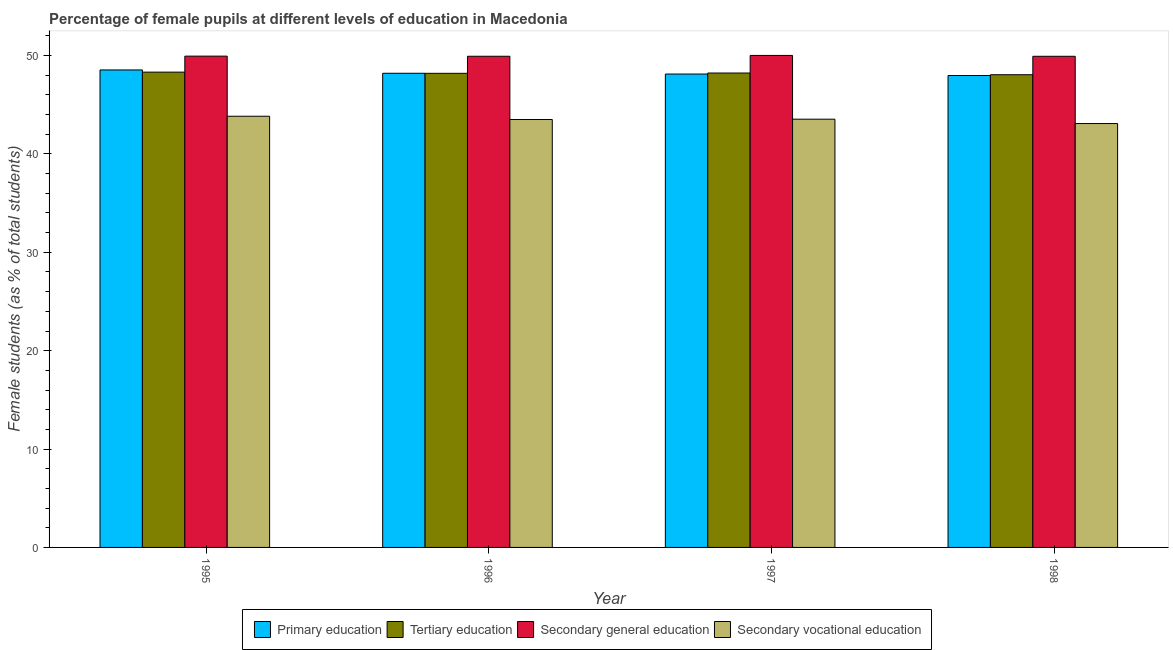How many bars are there on the 4th tick from the right?
Make the answer very short. 4. What is the percentage of female students in primary education in 1996?
Offer a terse response. 48.2. Across all years, what is the maximum percentage of female students in primary education?
Provide a short and direct response. 48.54. Across all years, what is the minimum percentage of female students in tertiary education?
Make the answer very short. 48.05. In which year was the percentage of female students in secondary vocational education maximum?
Offer a terse response. 1995. In which year was the percentage of female students in secondary vocational education minimum?
Provide a short and direct response. 1998. What is the total percentage of female students in secondary education in the graph?
Offer a very short reply. 199.81. What is the difference between the percentage of female students in tertiary education in 1996 and that in 1998?
Provide a short and direct response. 0.14. What is the difference between the percentage of female students in primary education in 1998 and the percentage of female students in tertiary education in 1996?
Your response must be concise. -0.23. What is the average percentage of female students in secondary education per year?
Your answer should be very brief. 49.95. What is the ratio of the percentage of female students in primary education in 1995 to that in 1997?
Provide a short and direct response. 1.01. Is the difference between the percentage of female students in secondary education in 1996 and 1997 greater than the difference between the percentage of female students in secondary vocational education in 1996 and 1997?
Offer a terse response. No. What is the difference between the highest and the second highest percentage of female students in secondary vocational education?
Your response must be concise. 0.3. What is the difference between the highest and the lowest percentage of female students in primary education?
Provide a short and direct response. 0.57. In how many years, is the percentage of female students in secondary vocational education greater than the average percentage of female students in secondary vocational education taken over all years?
Your answer should be very brief. 3. Is the sum of the percentage of female students in primary education in 1997 and 1998 greater than the maximum percentage of female students in tertiary education across all years?
Provide a succinct answer. Yes. Is it the case that in every year, the sum of the percentage of female students in secondary education and percentage of female students in secondary vocational education is greater than the sum of percentage of female students in primary education and percentage of female students in tertiary education?
Make the answer very short. No. What does the 1st bar from the left in 1995 represents?
Ensure brevity in your answer.  Primary education. What does the 3rd bar from the right in 1997 represents?
Offer a terse response. Tertiary education. Are all the bars in the graph horizontal?
Make the answer very short. No. How many years are there in the graph?
Provide a succinct answer. 4. What is the difference between two consecutive major ticks on the Y-axis?
Offer a very short reply. 10. Does the graph contain grids?
Keep it short and to the point. No. How many legend labels are there?
Your answer should be very brief. 4. How are the legend labels stacked?
Provide a succinct answer. Horizontal. What is the title of the graph?
Keep it short and to the point. Percentage of female pupils at different levels of education in Macedonia. What is the label or title of the X-axis?
Provide a succinct answer. Year. What is the label or title of the Y-axis?
Your answer should be compact. Female students (as % of total students). What is the Female students (as % of total students) of Primary education in 1995?
Your answer should be compact. 48.54. What is the Female students (as % of total students) in Tertiary education in 1995?
Your answer should be very brief. 48.31. What is the Female students (as % of total students) of Secondary general education in 1995?
Your answer should be compact. 49.94. What is the Female students (as % of total students) of Secondary vocational education in 1995?
Offer a terse response. 43.83. What is the Female students (as % of total students) of Primary education in 1996?
Make the answer very short. 48.2. What is the Female students (as % of total students) of Tertiary education in 1996?
Your answer should be very brief. 48.19. What is the Female students (as % of total students) in Secondary general education in 1996?
Provide a succinct answer. 49.93. What is the Female students (as % of total students) in Secondary vocational education in 1996?
Offer a terse response. 43.5. What is the Female students (as % of total students) in Primary education in 1997?
Provide a succinct answer. 48.12. What is the Female students (as % of total students) in Tertiary education in 1997?
Provide a succinct answer. 48.22. What is the Female students (as % of total students) in Secondary general education in 1997?
Give a very brief answer. 50.01. What is the Female students (as % of total students) in Secondary vocational education in 1997?
Offer a very short reply. 43.53. What is the Female students (as % of total students) in Primary education in 1998?
Provide a succinct answer. 47.97. What is the Female students (as % of total students) of Tertiary education in 1998?
Your answer should be compact. 48.05. What is the Female students (as % of total students) in Secondary general education in 1998?
Make the answer very short. 49.93. What is the Female students (as % of total students) of Secondary vocational education in 1998?
Keep it short and to the point. 43.09. Across all years, what is the maximum Female students (as % of total students) in Primary education?
Offer a very short reply. 48.54. Across all years, what is the maximum Female students (as % of total students) of Tertiary education?
Your answer should be very brief. 48.31. Across all years, what is the maximum Female students (as % of total students) in Secondary general education?
Keep it short and to the point. 50.01. Across all years, what is the maximum Female students (as % of total students) of Secondary vocational education?
Your answer should be very brief. 43.83. Across all years, what is the minimum Female students (as % of total students) of Primary education?
Your answer should be compact. 47.97. Across all years, what is the minimum Female students (as % of total students) in Tertiary education?
Make the answer very short. 48.05. Across all years, what is the minimum Female students (as % of total students) of Secondary general education?
Offer a terse response. 49.93. Across all years, what is the minimum Female students (as % of total students) in Secondary vocational education?
Provide a succinct answer. 43.09. What is the total Female students (as % of total students) in Primary education in the graph?
Provide a short and direct response. 192.83. What is the total Female students (as % of total students) of Tertiary education in the graph?
Offer a very short reply. 192.78. What is the total Female students (as % of total students) of Secondary general education in the graph?
Your answer should be compact. 199.81. What is the total Female students (as % of total students) in Secondary vocational education in the graph?
Your answer should be very brief. 173.95. What is the difference between the Female students (as % of total students) of Primary education in 1995 and that in 1996?
Your response must be concise. 0.34. What is the difference between the Female students (as % of total students) in Tertiary education in 1995 and that in 1996?
Your answer should be very brief. 0.12. What is the difference between the Female students (as % of total students) in Secondary general education in 1995 and that in 1996?
Your answer should be compact. 0.01. What is the difference between the Female students (as % of total students) in Secondary vocational education in 1995 and that in 1996?
Provide a succinct answer. 0.33. What is the difference between the Female students (as % of total students) in Primary education in 1995 and that in 1997?
Provide a short and direct response. 0.42. What is the difference between the Female students (as % of total students) of Tertiary education in 1995 and that in 1997?
Offer a terse response. 0.09. What is the difference between the Female students (as % of total students) of Secondary general education in 1995 and that in 1997?
Give a very brief answer. -0.07. What is the difference between the Female students (as % of total students) in Secondary vocational education in 1995 and that in 1997?
Your response must be concise. 0.3. What is the difference between the Female students (as % of total students) in Primary education in 1995 and that in 1998?
Make the answer very short. 0.57. What is the difference between the Female students (as % of total students) of Tertiary education in 1995 and that in 1998?
Your answer should be very brief. 0.26. What is the difference between the Female students (as % of total students) of Secondary general education in 1995 and that in 1998?
Your response must be concise. 0.02. What is the difference between the Female students (as % of total students) of Secondary vocational education in 1995 and that in 1998?
Offer a very short reply. 0.74. What is the difference between the Female students (as % of total students) in Primary education in 1996 and that in 1997?
Your response must be concise. 0.08. What is the difference between the Female students (as % of total students) in Tertiary education in 1996 and that in 1997?
Offer a terse response. -0.03. What is the difference between the Female students (as % of total students) of Secondary general education in 1996 and that in 1997?
Give a very brief answer. -0.08. What is the difference between the Female students (as % of total students) in Secondary vocational education in 1996 and that in 1997?
Give a very brief answer. -0.03. What is the difference between the Female students (as % of total students) in Primary education in 1996 and that in 1998?
Offer a terse response. 0.23. What is the difference between the Female students (as % of total students) in Tertiary education in 1996 and that in 1998?
Offer a very short reply. 0.14. What is the difference between the Female students (as % of total students) in Secondary general education in 1996 and that in 1998?
Offer a very short reply. 0. What is the difference between the Female students (as % of total students) of Secondary vocational education in 1996 and that in 1998?
Your answer should be compact. 0.41. What is the difference between the Female students (as % of total students) in Primary education in 1997 and that in 1998?
Make the answer very short. 0.15. What is the difference between the Female students (as % of total students) of Tertiary education in 1997 and that in 1998?
Ensure brevity in your answer.  0.17. What is the difference between the Female students (as % of total students) of Secondary general education in 1997 and that in 1998?
Your answer should be very brief. 0.09. What is the difference between the Female students (as % of total students) in Secondary vocational education in 1997 and that in 1998?
Offer a terse response. 0.44. What is the difference between the Female students (as % of total students) in Primary education in 1995 and the Female students (as % of total students) in Tertiary education in 1996?
Your answer should be compact. 0.34. What is the difference between the Female students (as % of total students) of Primary education in 1995 and the Female students (as % of total students) of Secondary general education in 1996?
Give a very brief answer. -1.39. What is the difference between the Female students (as % of total students) of Primary education in 1995 and the Female students (as % of total students) of Secondary vocational education in 1996?
Your answer should be very brief. 5.04. What is the difference between the Female students (as % of total students) of Tertiary education in 1995 and the Female students (as % of total students) of Secondary general education in 1996?
Ensure brevity in your answer.  -1.61. What is the difference between the Female students (as % of total students) in Tertiary education in 1995 and the Female students (as % of total students) in Secondary vocational education in 1996?
Your answer should be compact. 4.81. What is the difference between the Female students (as % of total students) of Secondary general education in 1995 and the Female students (as % of total students) of Secondary vocational education in 1996?
Make the answer very short. 6.44. What is the difference between the Female students (as % of total students) in Primary education in 1995 and the Female students (as % of total students) in Tertiary education in 1997?
Your response must be concise. 0.31. What is the difference between the Female students (as % of total students) in Primary education in 1995 and the Female students (as % of total students) in Secondary general education in 1997?
Provide a short and direct response. -1.48. What is the difference between the Female students (as % of total students) of Primary education in 1995 and the Female students (as % of total students) of Secondary vocational education in 1997?
Your answer should be very brief. 5. What is the difference between the Female students (as % of total students) in Tertiary education in 1995 and the Female students (as % of total students) in Secondary general education in 1997?
Offer a very short reply. -1.7. What is the difference between the Female students (as % of total students) of Tertiary education in 1995 and the Female students (as % of total students) of Secondary vocational education in 1997?
Ensure brevity in your answer.  4.78. What is the difference between the Female students (as % of total students) in Secondary general education in 1995 and the Female students (as % of total students) in Secondary vocational education in 1997?
Your answer should be compact. 6.41. What is the difference between the Female students (as % of total students) of Primary education in 1995 and the Female students (as % of total students) of Tertiary education in 1998?
Give a very brief answer. 0.49. What is the difference between the Female students (as % of total students) in Primary education in 1995 and the Female students (as % of total students) in Secondary general education in 1998?
Ensure brevity in your answer.  -1.39. What is the difference between the Female students (as % of total students) of Primary education in 1995 and the Female students (as % of total students) of Secondary vocational education in 1998?
Provide a succinct answer. 5.45. What is the difference between the Female students (as % of total students) of Tertiary education in 1995 and the Female students (as % of total students) of Secondary general education in 1998?
Your response must be concise. -1.61. What is the difference between the Female students (as % of total students) in Tertiary education in 1995 and the Female students (as % of total students) in Secondary vocational education in 1998?
Offer a very short reply. 5.23. What is the difference between the Female students (as % of total students) in Secondary general education in 1995 and the Female students (as % of total students) in Secondary vocational education in 1998?
Your response must be concise. 6.85. What is the difference between the Female students (as % of total students) in Primary education in 1996 and the Female students (as % of total students) in Tertiary education in 1997?
Offer a very short reply. -0.03. What is the difference between the Female students (as % of total students) in Primary education in 1996 and the Female students (as % of total students) in Secondary general education in 1997?
Offer a very short reply. -1.82. What is the difference between the Female students (as % of total students) of Primary education in 1996 and the Female students (as % of total students) of Secondary vocational education in 1997?
Your answer should be very brief. 4.67. What is the difference between the Female students (as % of total students) in Tertiary education in 1996 and the Female students (as % of total students) in Secondary general education in 1997?
Your answer should be compact. -1.82. What is the difference between the Female students (as % of total students) of Tertiary education in 1996 and the Female students (as % of total students) of Secondary vocational education in 1997?
Offer a terse response. 4.66. What is the difference between the Female students (as % of total students) of Secondary general education in 1996 and the Female students (as % of total students) of Secondary vocational education in 1997?
Keep it short and to the point. 6.4. What is the difference between the Female students (as % of total students) of Primary education in 1996 and the Female students (as % of total students) of Tertiary education in 1998?
Your answer should be very brief. 0.15. What is the difference between the Female students (as % of total students) of Primary education in 1996 and the Female students (as % of total students) of Secondary general education in 1998?
Provide a succinct answer. -1.73. What is the difference between the Female students (as % of total students) of Primary education in 1996 and the Female students (as % of total students) of Secondary vocational education in 1998?
Offer a very short reply. 5.11. What is the difference between the Female students (as % of total students) in Tertiary education in 1996 and the Female students (as % of total students) in Secondary general education in 1998?
Ensure brevity in your answer.  -1.73. What is the difference between the Female students (as % of total students) of Tertiary education in 1996 and the Female students (as % of total students) of Secondary vocational education in 1998?
Provide a succinct answer. 5.11. What is the difference between the Female students (as % of total students) in Secondary general education in 1996 and the Female students (as % of total students) in Secondary vocational education in 1998?
Your answer should be compact. 6.84. What is the difference between the Female students (as % of total students) of Primary education in 1997 and the Female students (as % of total students) of Tertiary education in 1998?
Make the answer very short. 0.07. What is the difference between the Female students (as % of total students) in Primary education in 1997 and the Female students (as % of total students) in Secondary general education in 1998?
Keep it short and to the point. -1.8. What is the difference between the Female students (as % of total students) of Primary education in 1997 and the Female students (as % of total students) of Secondary vocational education in 1998?
Ensure brevity in your answer.  5.03. What is the difference between the Female students (as % of total students) of Tertiary education in 1997 and the Female students (as % of total students) of Secondary general education in 1998?
Give a very brief answer. -1.7. What is the difference between the Female students (as % of total students) of Tertiary education in 1997 and the Female students (as % of total students) of Secondary vocational education in 1998?
Make the answer very short. 5.14. What is the difference between the Female students (as % of total students) in Secondary general education in 1997 and the Female students (as % of total students) in Secondary vocational education in 1998?
Provide a succinct answer. 6.92. What is the average Female students (as % of total students) of Primary education per year?
Your answer should be very brief. 48.21. What is the average Female students (as % of total students) in Tertiary education per year?
Your response must be concise. 48.2. What is the average Female students (as % of total students) in Secondary general education per year?
Provide a succinct answer. 49.95. What is the average Female students (as % of total students) of Secondary vocational education per year?
Offer a terse response. 43.49. In the year 1995, what is the difference between the Female students (as % of total students) of Primary education and Female students (as % of total students) of Tertiary education?
Ensure brevity in your answer.  0.22. In the year 1995, what is the difference between the Female students (as % of total students) in Primary education and Female students (as % of total students) in Secondary general education?
Ensure brevity in your answer.  -1.4. In the year 1995, what is the difference between the Female students (as % of total students) of Primary education and Female students (as % of total students) of Secondary vocational education?
Ensure brevity in your answer.  4.71. In the year 1995, what is the difference between the Female students (as % of total students) in Tertiary education and Female students (as % of total students) in Secondary general education?
Make the answer very short. -1.63. In the year 1995, what is the difference between the Female students (as % of total students) in Tertiary education and Female students (as % of total students) in Secondary vocational education?
Keep it short and to the point. 4.48. In the year 1995, what is the difference between the Female students (as % of total students) in Secondary general education and Female students (as % of total students) in Secondary vocational education?
Offer a very short reply. 6.11. In the year 1996, what is the difference between the Female students (as % of total students) of Primary education and Female students (as % of total students) of Tertiary education?
Provide a short and direct response. 0. In the year 1996, what is the difference between the Female students (as % of total students) of Primary education and Female students (as % of total students) of Secondary general education?
Your response must be concise. -1.73. In the year 1996, what is the difference between the Female students (as % of total students) in Primary education and Female students (as % of total students) in Secondary vocational education?
Your response must be concise. 4.7. In the year 1996, what is the difference between the Female students (as % of total students) of Tertiary education and Female students (as % of total students) of Secondary general education?
Give a very brief answer. -1.73. In the year 1996, what is the difference between the Female students (as % of total students) of Tertiary education and Female students (as % of total students) of Secondary vocational education?
Your response must be concise. 4.69. In the year 1996, what is the difference between the Female students (as % of total students) in Secondary general education and Female students (as % of total students) in Secondary vocational education?
Ensure brevity in your answer.  6.43. In the year 1997, what is the difference between the Female students (as % of total students) in Primary education and Female students (as % of total students) in Tertiary education?
Your response must be concise. -0.1. In the year 1997, what is the difference between the Female students (as % of total students) in Primary education and Female students (as % of total students) in Secondary general education?
Offer a very short reply. -1.89. In the year 1997, what is the difference between the Female students (as % of total students) in Primary education and Female students (as % of total students) in Secondary vocational education?
Your response must be concise. 4.59. In the year 1997, what is the difference between the Female students (as % of total students) in Tertiary education and Female students (as % of total students) in Secondary general education?
Provide a succinct answer. -1.79. In the year 1997, what is the difference between the Female students (as % of total students) of Tertiary education and Female students (as % of total students) of Secondary vocational education?
Provide a short and direct response. 4.69. In the year 1997, what is the difference between the Female students (as % of total students) in Secondary general education and Female students (as % of total students) in Secondary vocational education?
Provide a succinct answer. 6.48. In the year 1998, what is the difference between the Female students (as % of total students) in Primary education and Female students (as % of total students) in Tertiary education?
Ensure brevity in your answer.  -0.08. In the year 1998, what is the difference between the Female students (as % of total students) of Primary education and Female students (as % of total students) of Secondary general education?
Provide a short and direct response. -1.95. In the year 1998, what is the difference between the Female students (as % of total students) in Primary education and Female students (as % of total students) in Secondary vocational education?
Offer a terse response. 4.88. In the year 1998, what is the difference between the Female students (as % of total students) in Tertiary education and Female students (as % of total students) in Secondary general education?
Offer a terse response. -1.87. In the year 1998, what is the difference between the Female students (as % of total students) of Tertiary education and Female students (as % of total students) of Secondary vocational education?
Your response must be concise. 4.96. In the year 1998, what is the difference between the Female students (as % of total students) of Secondary general education and Female students (as % of total students) of Secondary vocational education?
Ensure brevity in your answer.  6.84. What is the ratio of the Female students (as % of total students) in Secondary vocational education in 1995 to that in 1996?
Your answer should be very brief. 1.01. What is the ratio of the Female students (as % of total students) in Primary education in 1995 to that in 1997?
Make the answer very short. 1.01. What is the ratio of the Female students (as % of total students) of Tertiary education in 1995 to that in 1997?
Provide a succinct answer. 1. What is the ratio of the Female students (as % of total students) of Primary education in 1995 to that in 1998?
Provide a succinct answer. 1.01. What is the ratio of the Female students (as % of total students) of Tertiary education in 1995 to that in 1998?
Your answer should be very brief. 1.01. What is the ratio of the Female students (as % of total students) of Secondary vocational education in 1995 to that in 1998?
Provide a short and direct response. 1.02. What is the ratio of the Female students (as % of total students) of Tertiary education in 1996 to that in 1998?
Your response must be concise. 1. What is the ratio of the Female students (as % of total students) of Secondary general education in 1996 to that in 1998?
Offer a very short reply. 1. What is the ratio of the Female students (as % of total students) of Secondary vocational education in 1996 to that in 1998?
Your answer should be compact. 1.01. What is the ratio of the Female students (as % of total students) of Secondary general education in 1997 to that in 1998?
Your response must be concise. 1. What is the ratio of the Female students (as % of total students) of Secondary vocational education in 1997 to that in 1998?
Ensure brevity in your answer.  1.01. What is the difference between the highest and the second highest Female students (as % of total students) of Primary education?
Give a very brief answer. 0.34. What is the difference between the highest and the second highest Female students (as % of total students) of Tertiary education?
Keep it short and to the point. 0.09. What is the difference between the highest and the second highest Female students (as % of total students) of Secondary general education?
Ensure brevity in your answer.  0.07. What is the difference between the highest and the second highest Female students (as % of total students) of Secondary vocational education?
Offer a terse response. 0.3. What is the difference between the highest and the lowest Female students (as % of total students) in Primary education?
Offer a very short reply. 0.57. What is the difference between the highest and the lowest Female students (as % of total students) of Tertiary education?
Ensure brevity in your answer.  0.26. What is the difference between the highest and the lowest Female students (as % of total students) of Secondary general education?
Make the answer very short. 0.09. What is the difference between the highest and the lowest Female students (as % of total students) in Secondary vocational education?
Offer a very short reply. 0.74. 